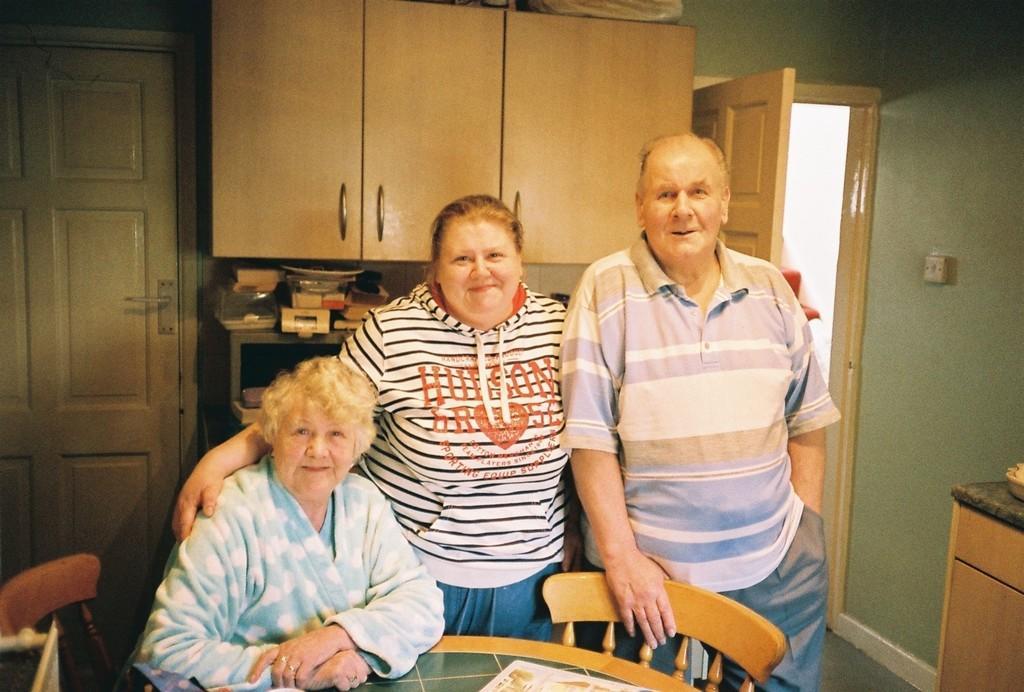In one or two sentences, can you explain what this image depicts? This is an inside view. Here I can see a man and two women are smiling and giving pose for the picture. One woman is sitting on a chair. At the bottom there is a table on which I can see a newspaper. On the right side there is a table which is placed beside the wall. In the background, I can see two doors, table on which few objects are placed. At the top there is a cupboard. 